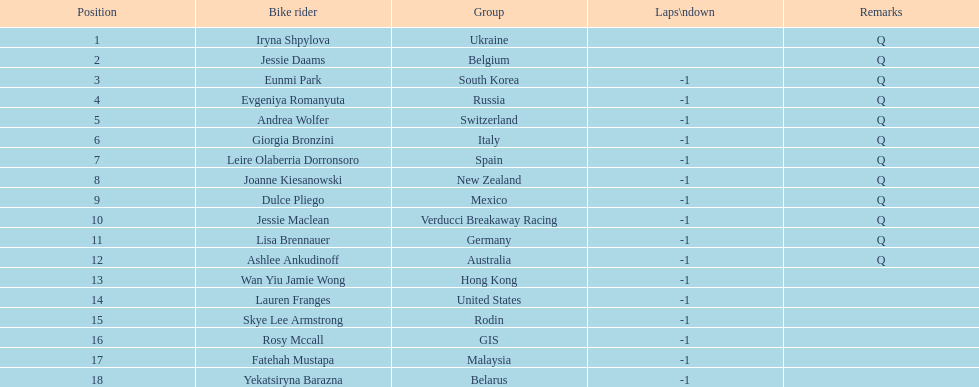Who was the competitor that finished above jessie maclean? Dulce Pliego. 